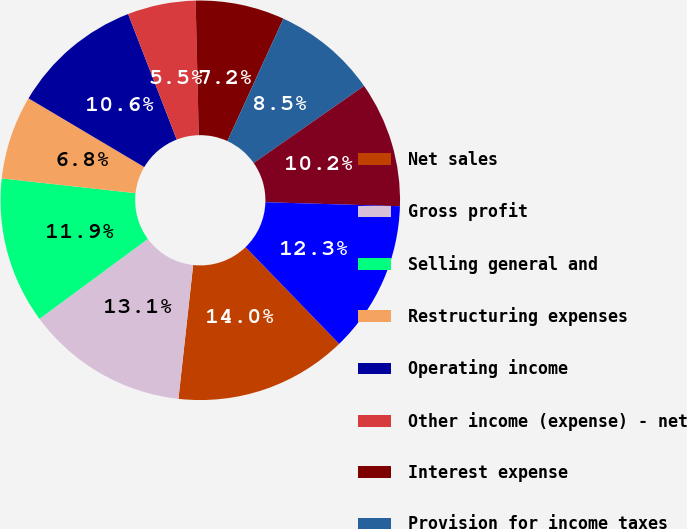Convert chart to OTSL. <chart><loc_0><loc_0><loc_500><loc_500><pie_chart><fcel>Net sales<fcel>Gross profit<fcel>Selling general and<fcel>Restructuring expenses<fcel>Operating income<fcel>Other income (expense) - net<fcel>Interest expense<fcel>Provision for income taxes<fcel>Net income<fcel>Current assets<nl><fcel>13.98%<fcel>13.14%<fcel>11.86%<fcel>6.78%<fcel>10.59%<fcel>5.51%<fcel>7.2%<fcel>8.47%<fcel>10.17%<fcel>12.29%<nl></chart> 